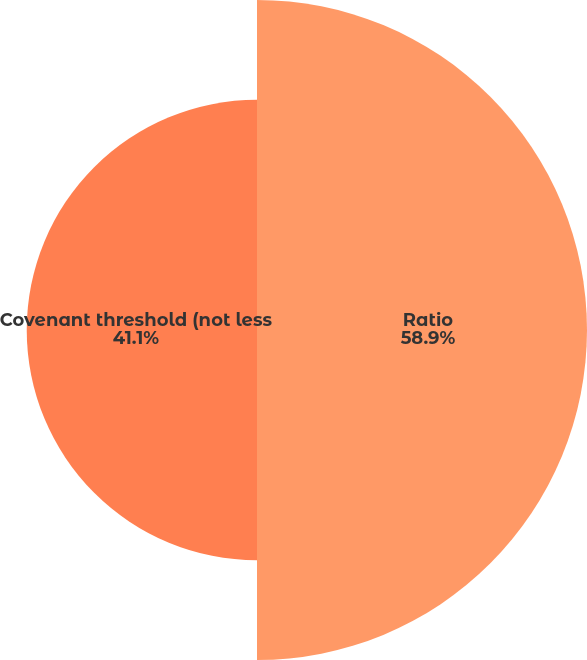Convert chart. <chart><loc_0><loc_0><loc_500><loc_500><pie_chart><fcel>Ratio<fcel>Covenant threshold (not less<nl><fcel>58.9%<fcel>41.1%<nl></chart> 